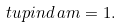<formula> <loc_0><loc_0><loc_500><loc_500>\ t u p { i n d \, } \L a m = 1 .</formula> 